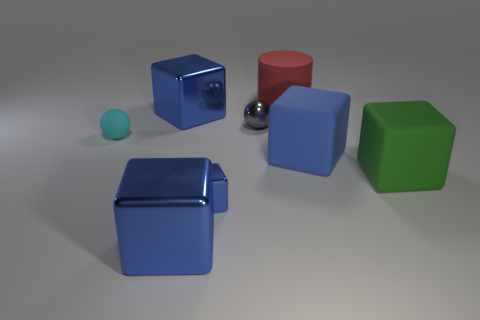Is there a blue thing of the same size as the gray object?
Your answer should be very brief. Yes. What is the material of the cylinder that is the same size as the blue matte thing?
Offer a very short reply. Rubber. There is a sphere in front of the small gray shiny ball; how big is it?
Your answer should be very brief. Small. How big is the red thing?
Offer a very short reply. Large. Do the green matte thing and the blue block behind the big blue rubber object have the same size?
Your response must be concise. Yes. What color is the rubber object that is on the right side of the blue object that is to the right of the cylinder?
Provide a succinct answer. Green. Is the number of gray things left of the tiny cube the same as the number of big blue things that are to the right of the red rubber cylinder?
Offer a terse response. No. Is the material of the blue thing on the right side of the red rubber thing the same as the green thing?
Your response must be concise. Yes. There is a big thing that is behind the cyan thing and to the left of the red thing; what is its color?
Give a very brief answer. Blue. There is a big blue metal thing behind the small gray thing; what number of large blue metal things are on the right side of it?
Make the answer very short. 1. 